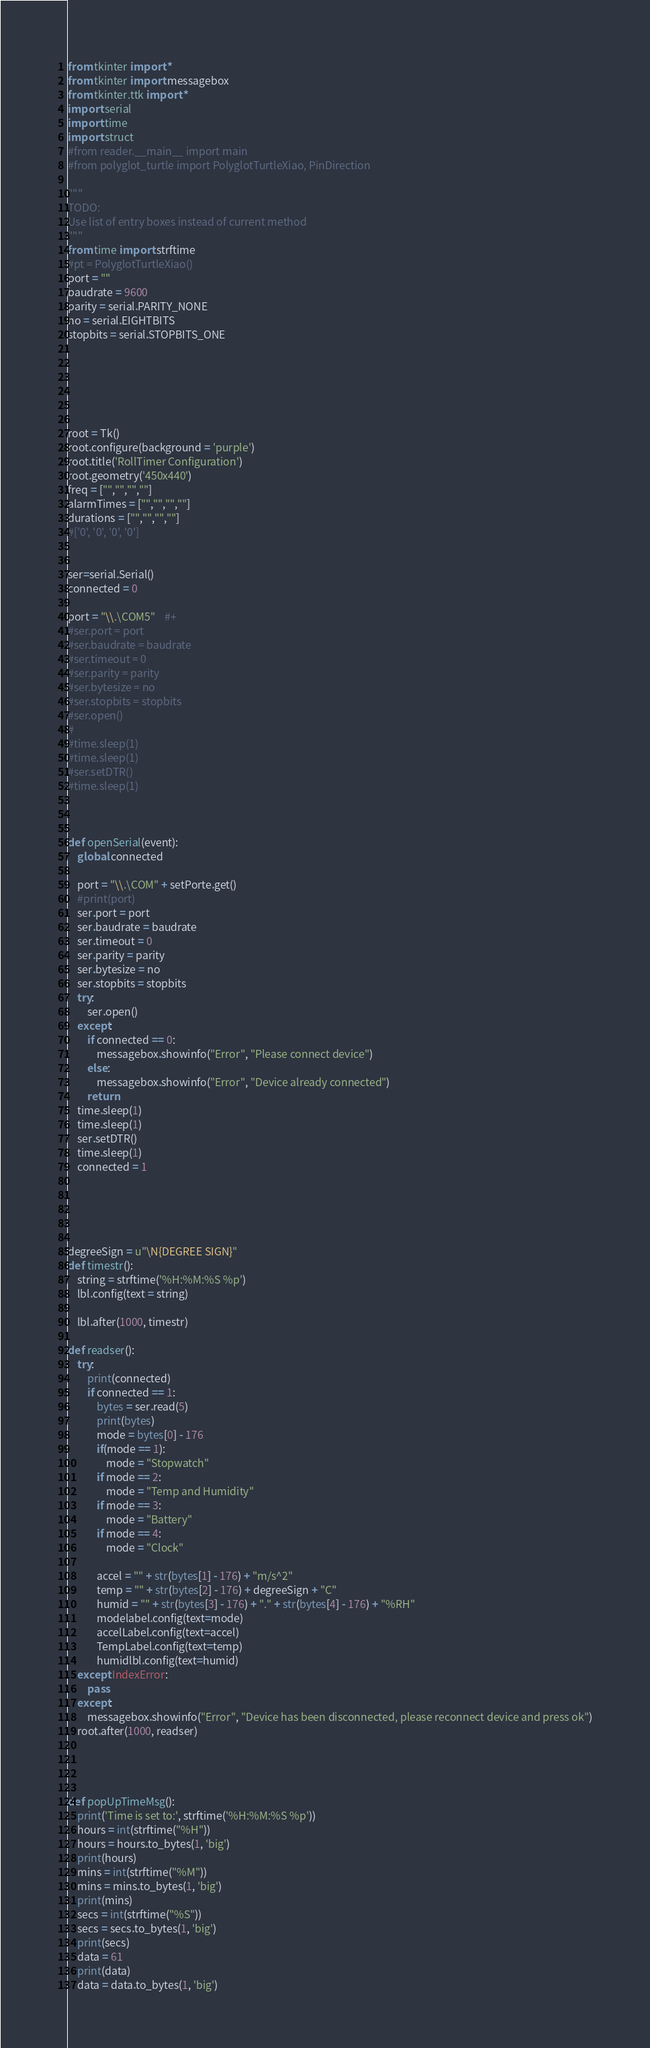<code> <loc_0><loc_0><loc_500><loc_500><_Python_>from tkinter import *
from tkinter import messagebox
from tkinter.ttk import *
import serial
import time
import struct
#from reader.__main__ import main
#from polyglot_turtle import PolyglotTurtleXiao, PinDirection

"""
TODO:
Use list of entry boxes instead of current method
"""
from time import strftime
#pt = PolyglotTurtleXiao()
port = ""
baudrate = 9600
parity = serial.PARITY_NONE
no = serial.EIGHTBITS
stopbits = serial.STOPBITS_ONE






root = Tk()
root.configure(background = 'purple')
root.title('RollTimer Configuration')
root.geometry('450x440')
freq = ["","","",""]
alarmTimes = ["","","",""]
durations = ["","","",""]
#['0', '0', '0', '0']


ser=serial.Serial()
connected = 0

port = "\\.\COM5"    #+
#ser.port = port
#ser.baudrate = baudrate
#ser.timeout = 0
#ser.parity = parity
#ser.bytesize = no
#ser.stopbits = stopbits
#ser.open()
#
#time.sleep(1)
#time.sleep(1)
#ser.setDTR()
#time.sleep(1)



def openSerial(event):
    global connected

    port = "\\.\COM" + setPorte.get()
    #print(port)
    ser.port = port
    ser.baudrate = baudrate
    ser.timeout = 0
    ser.parity = parity
    ser.bytesize = no
    ser.stopbits = stopbits
    try:
        ser.open()
    except:
        if connected == 0:
            messagebox.showinfo("Error", "Please connect device")
        else:
            messagebox.showinfo("Error", "Device already connected")
        return
    time.sleep(1)
    time.sleep(1)
    ser.setDTR()
    time.sleep(1)
    connected = 1





degreeSign = u"\N{DEGREE SIGN}"
def timestr():
    string = strftime('%H:%M:%S %p')
    lbl.config(text = string)

    lbl.after(1000, timestr)

def readser():
    try:
        print(connected)
        if connected == 1:
            bytes = ser.read(5)
            print(bytes)
            mode = bytes[0] - 176
            if(mode == 1):
                mode = "Stopwatch"
            if mode == 2:
                mode = "Temp and Humidity"
            if mode == 3:
                mode = "Battery"
            if mode == 4:
                mode = "Clock"

            accel = "" + str(bytes[1] - 176) + "m/s^2"
            temp = "" + str(bytes[2] - 176) + degreeSign + "C"
            humid = "" + str(bytes[3] - 176) + "." + str(bytes[4] - 176) + "%RH"
            modelabel.config(text=mode)
            accelLabel.config(text=accel)
            TempLabel.config(text=temp)
            humidlbl.config(text=humid)
    except IndexError:
        pass
    except:
        messagebox.showinfo("Error", "Device has been disconnected, please reconnect device and press ok")
    root.after(1000, readser)




def popUpTimeMsg():
    print('Time is set to:', strftime('%H:%M:%S %p'))
    hours = int(strftime("%H"))
    hours = hours.to_bytes(1, 'big')
    print(hours)
    mins = int(strftime("%M"))
    mins = mins.to_bytes(1, 'big')
    print(mins)
    secs = int(strftime("%S"))
    secs = secs.to_bytes(1, 'big')
    print(secs)
    data = 61
    print(data)
    data = data.to_bytes(1, 'big')
</code> 